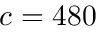<formula> <loc_0><loc_0><loc_500><loc_500>c = 4 8 0</formula> 